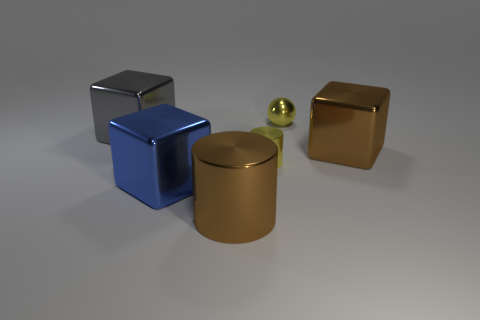Add 3 tiny balls. How many objects exist? 9 Subtract all cylinders. How many objects are left? 4 Subtract all red balls. Subtract all brown objects. How many objects are left? 4 Add 2 big blue shiny cubes. How many big blue shiny cubes are left? 3 Add 1 tiny yellow metallic things. How many tiny yellow metallic things exist? 3 Subtract 1 blue cubes. How many objects are left? 5 